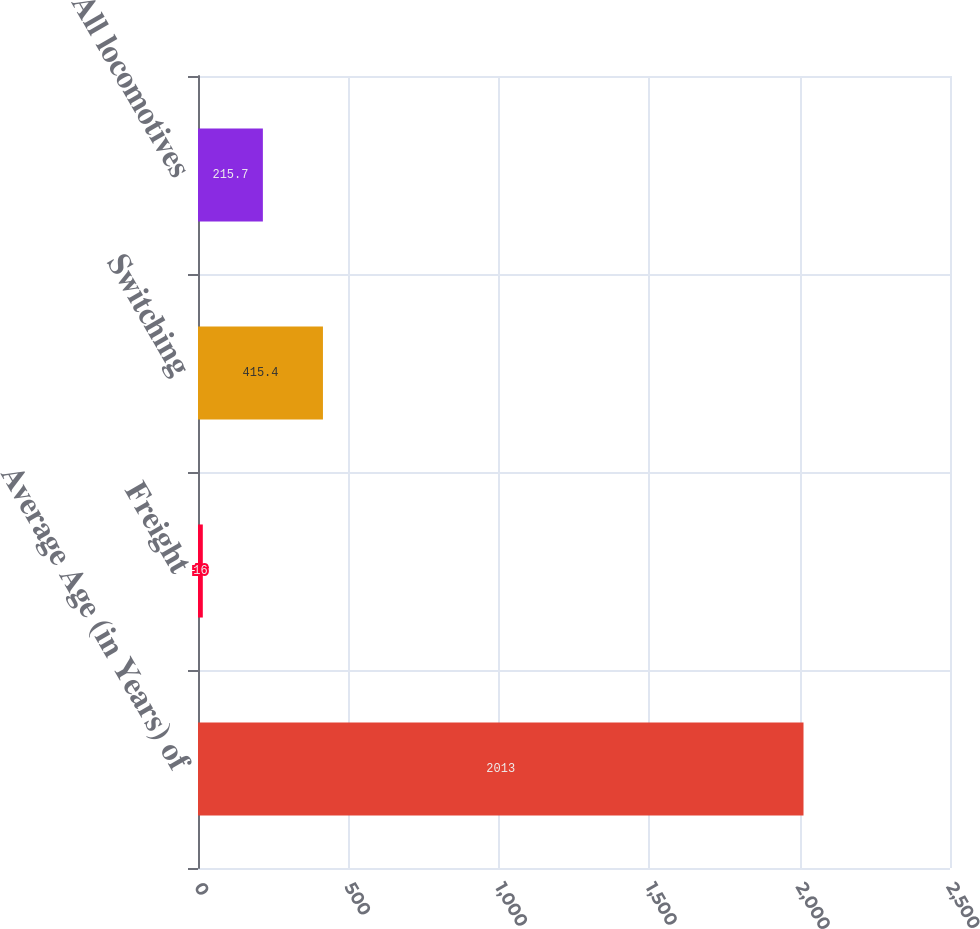Convert chart. <chart><loc_0><loc_0><loc_500><loc_500><bar_chart><fcel>Average Age (in Years) of<fcel>Freight<fcel>Switching<fcel>All locomotives<nl><fcel>2013<fcel>16<fcel>415.4<fcel>215.7<nl></chart> 